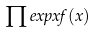<formula> <loc_0><loc_0><loc_500><loc_500>\prod e x p x f ( x )</formula> 